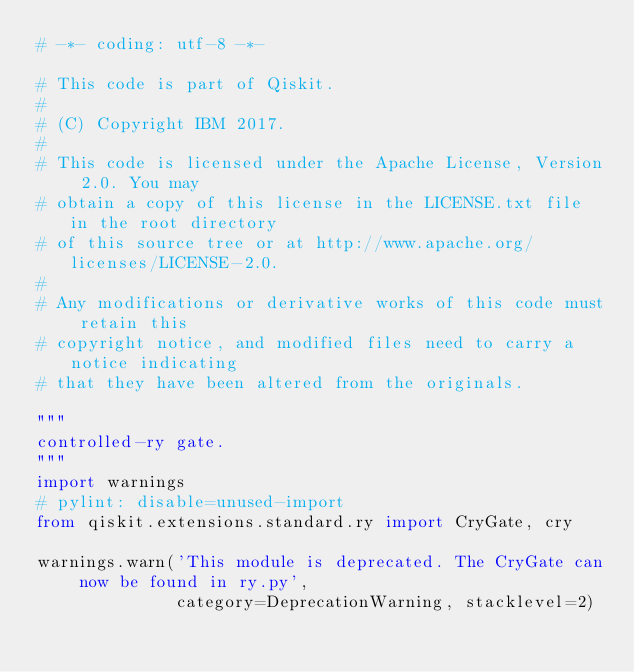Convert code to text. <code><loc_0><loc_0><loc_500><loc_500><_Python_># -*- coding: utf-8 -*-

# This code is part of Qiskit.
#
# (C) Copyright IBM 2017.
#
# This code is licensed under the Apache License, Version 2.0. You may
# obtain a copy of this license in the LICENSE.txt file in the root directory
# of this source tree or at http://www.apache.org/licenses/LICENSE-2.0.
#
# Any modifications or derivative works of this code must retain this
# copyright notice, and modified files need to carry a notice indicating
# that they have been altered from the originals.

"""
controlled-ry gate.
"""
import warnings
# pylint: disable=unused-import
from qiskit.extensions.standard.ry import CryGate, cry

warnings.warn('This module is deprecated. The CryGate can now be found in ry.py',
              category=DeprecationWarning, stacklevel=2)
</code> 